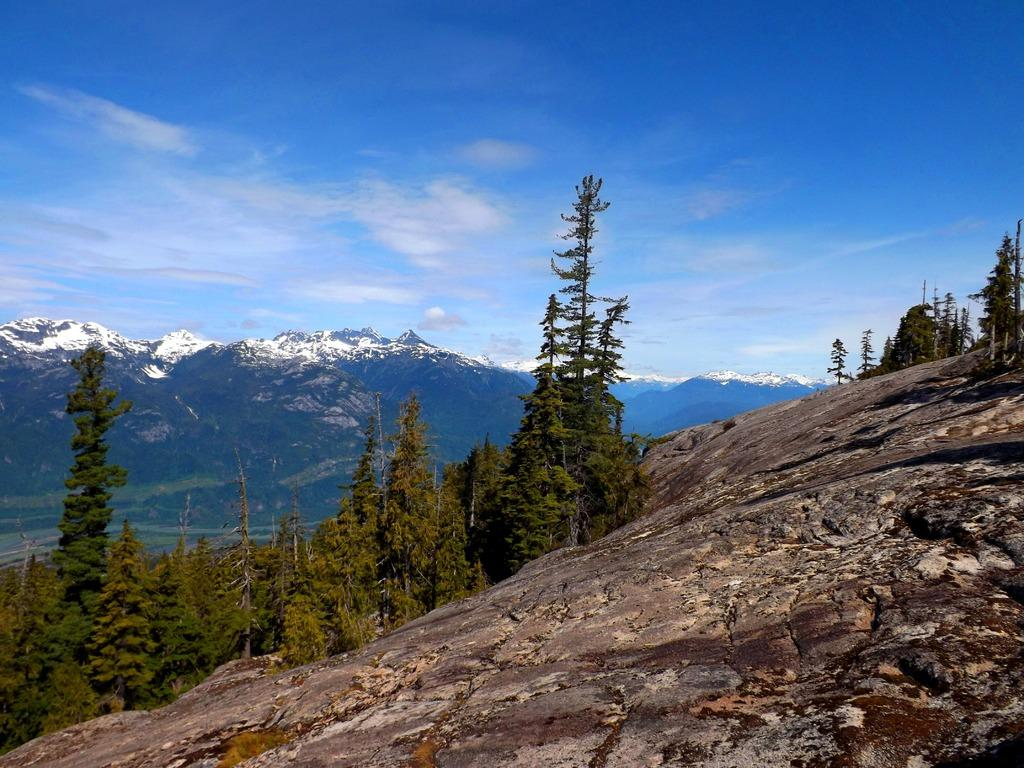What is located at the bottom of the image? There is a rock at the bottom of the image. What type of vegetation can be seen in the image? There are trees in the image. What geographical feature is visible in the background? In the background, there are mountains covered with snow. What is visible at the top of the image? The sky is visible at the top of the image. What can be seen in the sky? Clouds are present in the sky. What type of curtain is hanging from the rock in the image? There is no curtain present in the image; it features a rock, trees, mountains, sky, and clouds. How does the love between the trees manifest in the image? There is no indication of love between the trees or any other elements in the image. 